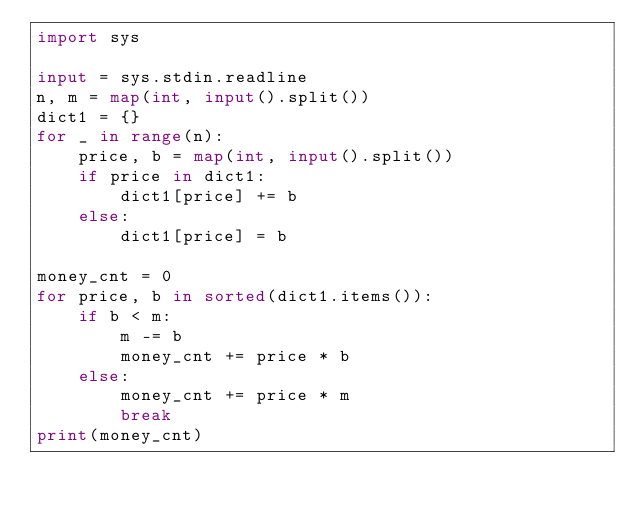<code> <loc_0><loc_0><loc_500><loc_500><_Python_>import sys

input = sys.stdin.readline
n, m = map(int, input().split())
dict1 = {}
for _ in range(n):
    price, b = map(int, input().split())
    if price in dict1:
        dict1[price] += b
    else:
        dict1[price] = b

money_cnt = 0
for price, b in sorted(dict1.items()):
    if b < m:
        m -= b
        money_cnt += price * b
    else:
        money_cnt += price * m
        break
print(money_cnt)</code> 